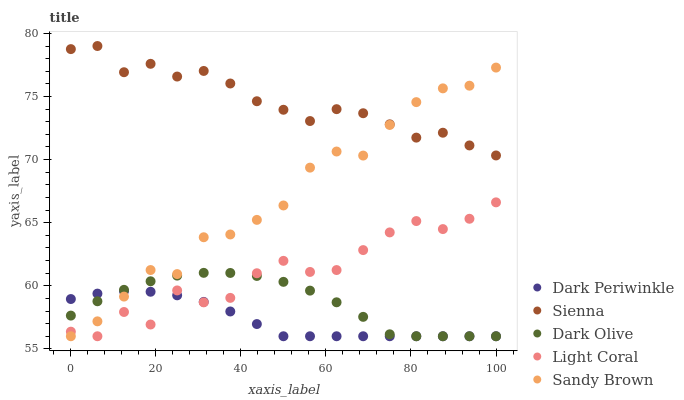Does Dark Periwinkle have the minimum area under the curve?
Answer yes or no. Yes. Does Sienna have the maximum area under the curve?
Answer yes or no. Yes. Does Light Coral have the minimum area under the curve?
Answer yes or no. No. Does Light Coral have the maximum area under the curve?
Answer yes or no. No. Is Dark Periwinkle the smoothest?
Answer yes or no. Yes. Is Light Coral the roughest?
Answer yes or no. Yes. Is Dark Olive the smoothest?
Answer yes or no. No. Is Dark Olive the roughest?
Answer yes or no. No. Does Light Coral have the lowest value?
Answer yes or no. Yes. Does Sienna have the highest value?
Answer yes or no. Yes. Does Light Coral have the highest value?
Answer yes or no. No. Is Light Coral less than Sienna?
Answer yes or no. Yes. Is Sienna greater than Light Coral?
Answer yes or no. Yes. Does Sandy Brown intersect Dark Periwinkle?
Answer yes or no. Yes. Is Sandy Brown less than Dark Periwinkle?
Answer yes or no. No. Is Sandy Brown greater than Dark Periwinkle?
Answer yes or no. No. Does Light Coral intersect Sienna?
Answer yes or no. No. 